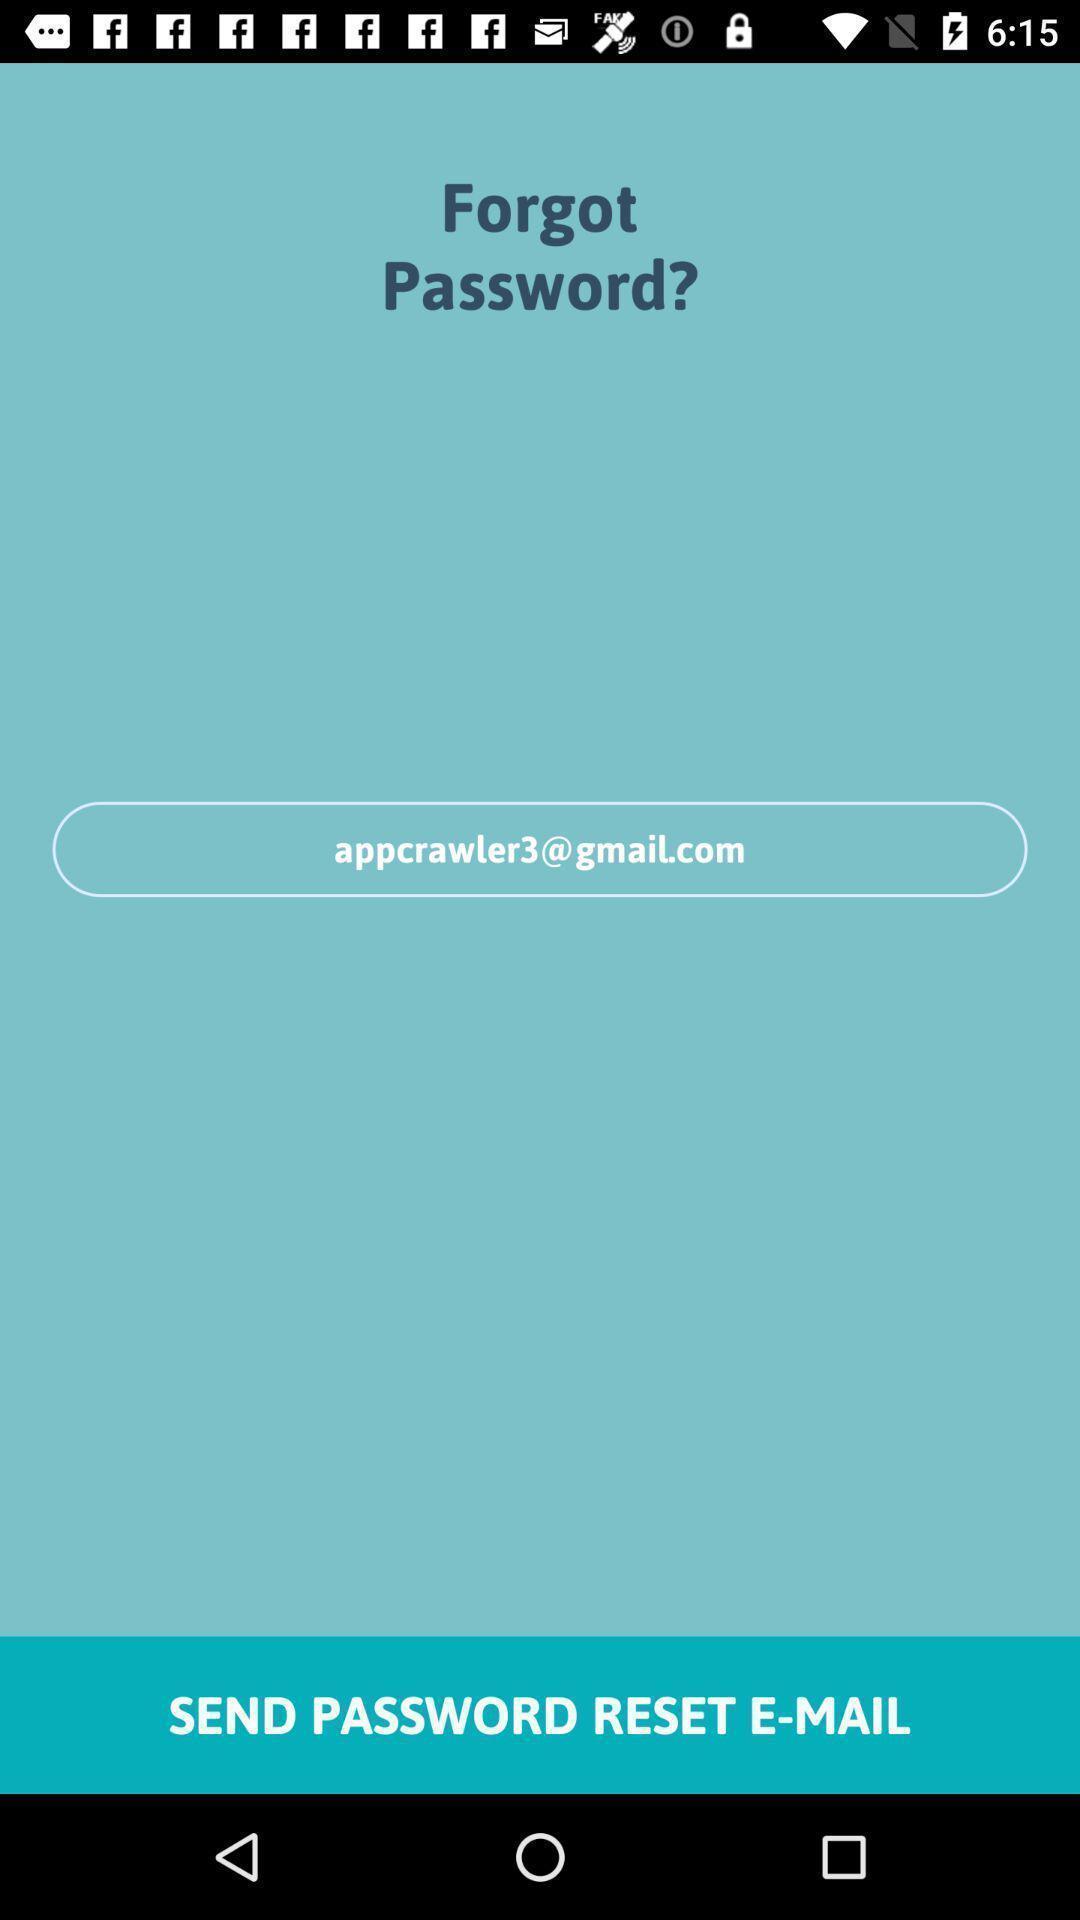Explain what's happening in this screen capture. Screen displaying the option for forgot password. 